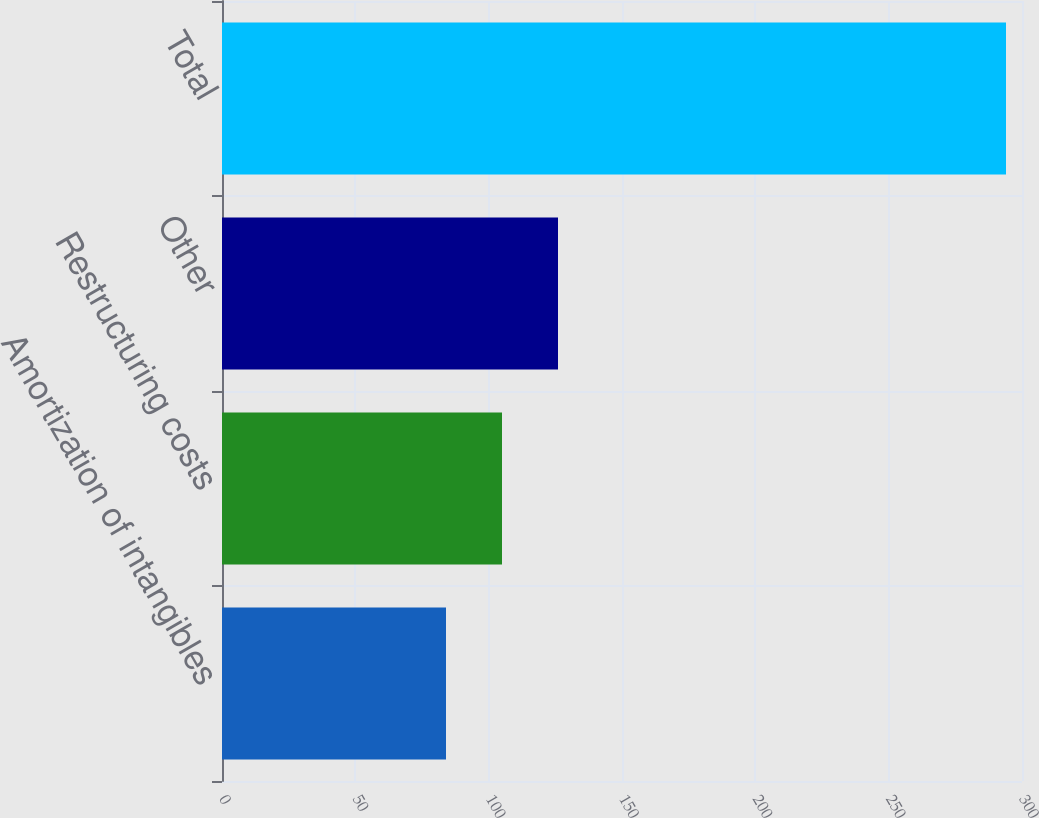Convert chart to OTSL. <chart><loc_0><loc_0><loc_500><loc_500><bar_chart><fcel>Amortization of intangibles<fcel>Restructuring costs<fcel>Other<fcel>Total<nl><fcel>84<fcel>105<fcel>126<fcel>294<nl></chart> 